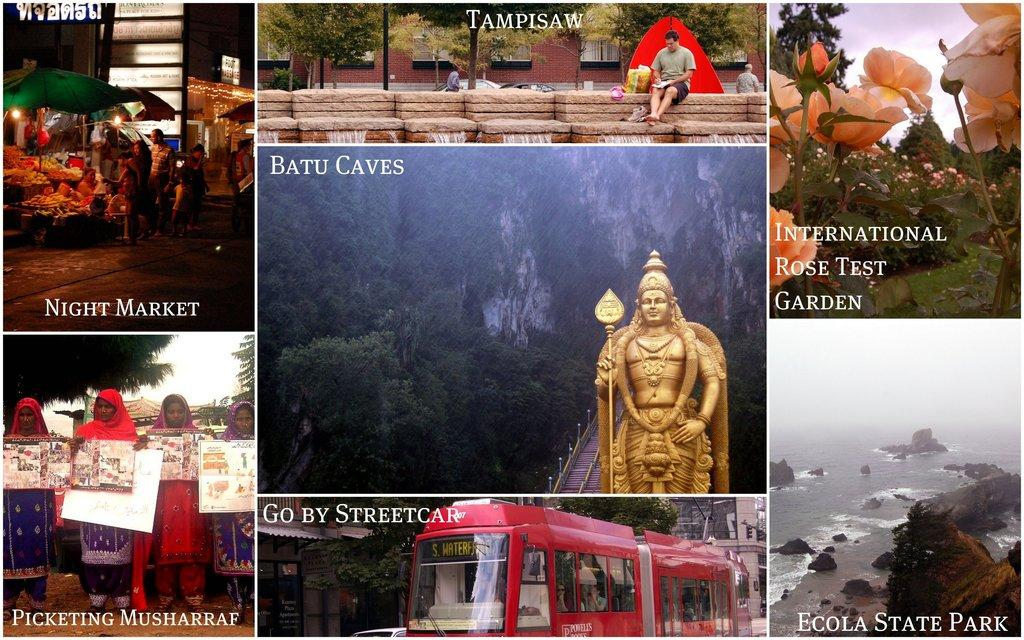<image>
Describe the image concisely. A multiple picture frame of various settings including Ecola state . 